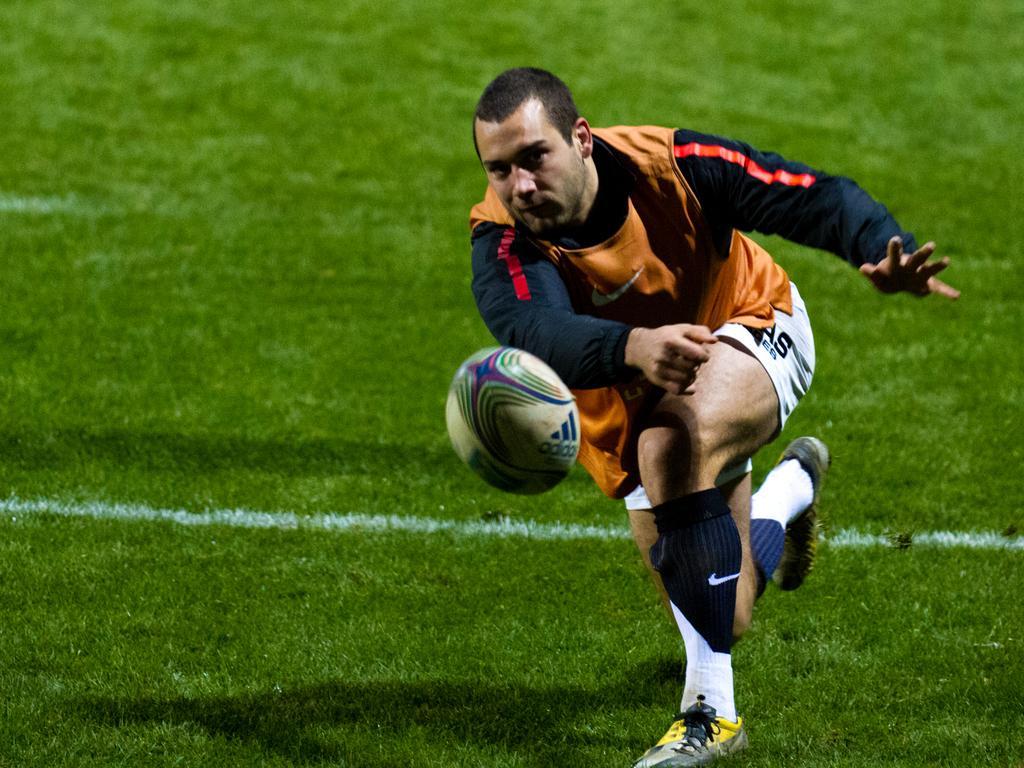Could you give a brief overview of what you see in this image? In this picture I can see a person playing with ball on the grass. 